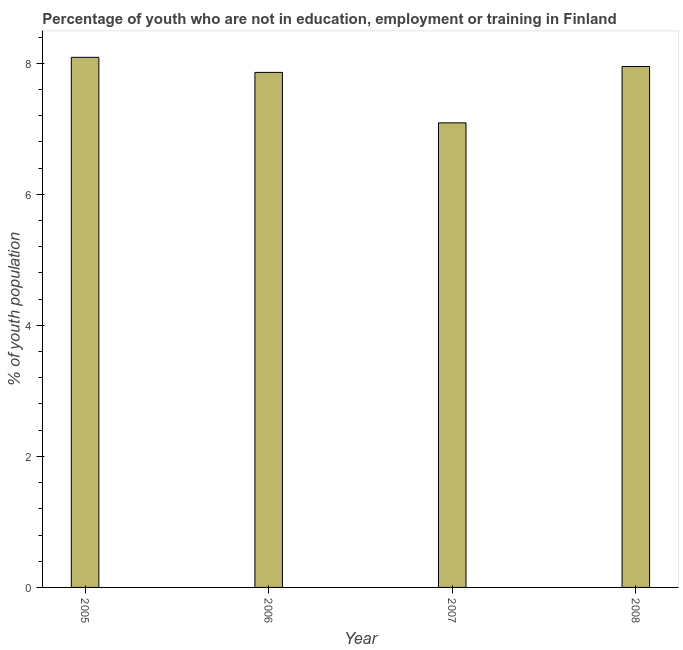Does the graph contain grids?
Ensure brevity in your answer.  No. What is the title of the graph?
Offer a very short reply. Percentage of youth who are not in education, employment or training in Finland. What is the label or title of the X-axis?
Ensure brevity in your answer.  Year. What is the label or title of the Y-axis?
Offer a very short reply. % of youth population. What is the unemployed youth population in 2005?
Your answer should be very brief. 8.09. Across all years, what is the maximum unemployed youth population?
Your answer should be very brief. 8.09. Across all years, what is the minimum unemployed youth population?
Provide a short and direct response. 7.09. What is the sum of the unemployed youth population?
Keep it short and to the point. 30.99. What is the difference between the unemployed youth population in 2005 and 2006?
Give a very brief answer. 0.23. What is the average unemployed youth population per year?
Offer a very short reply. 7.75. What is the median unemployed youth population?
Provide a short and direct response. 7.9. Do a majority of the years between 2008 and 2007 (inclusive) have unemployed youth population greater than 2.4 %?
Your answer should be compact. No. What is the ratio of the unemployed youth population in 2005 to that in 2007?
Make the answer very short. 1.14. Is the unemployed youth population in 2006 less than that in 2007?
Ensure brevity in your answer.  No. Is the difference between the unemployed youth population in 2005 and 2007 greater than the difference between any two years?
Make the answer very short. Yes. What is the difference between the highest and the second highest unemployed youth population?
Offer a terse response. 0.14. What is the difference between the highest and the lowest unemployed youth population?
Your answer should be very brief. 1. How many years are there in the graph?
Your answer should be compact. 4. Are the values on the major ticks of Y-axis written in scientific E-notation?
Your answer should be very brief. No. What is the % of youth population in 2005?
Give a very brief answer. 8.09. What is the % of youth population of 2006?
Offer a terse response. 7.86. What is the % of youth population in 2007?
Offer a terse response. 7.09. What is the % of youth population in 2008?
Your answer should be compact. 7.95. What is the difference between the % of youth population in 2005 and 2006?
Keep it short and to the point. 0.23. What is the difference between the % of youth population in 2005 and 2007?
Provide a short and direct response. 1. What is the difference between the % of youth population in 2005 and 2008?
Provide a succinct answer. 0.14. What is the difference between the % of youth population in 2006 and 2007?
Your response must be concise. 0.77. What is the difference between the % of youth population in 2006 and 2008?
Provide a succinct answer. -0.09. What is the difference between the % of youth population in 2007 and 2008?
Make the answer very short. -0.86. What is the ratio of the % of youth population in 2005 to that in 2007?
Offer a very short reply. 1.14. What is the ratio of the % of youth population in 2005 to that in 2008?
Make the answer very short. 1.02. What is the ratio of the % of youth population in 2006 to that in 2007?
Your response must be concise. 1.11. What is the ratio of the % of youth population in 2007 to that in 2008?
Give a very brief answer. 0.89. 